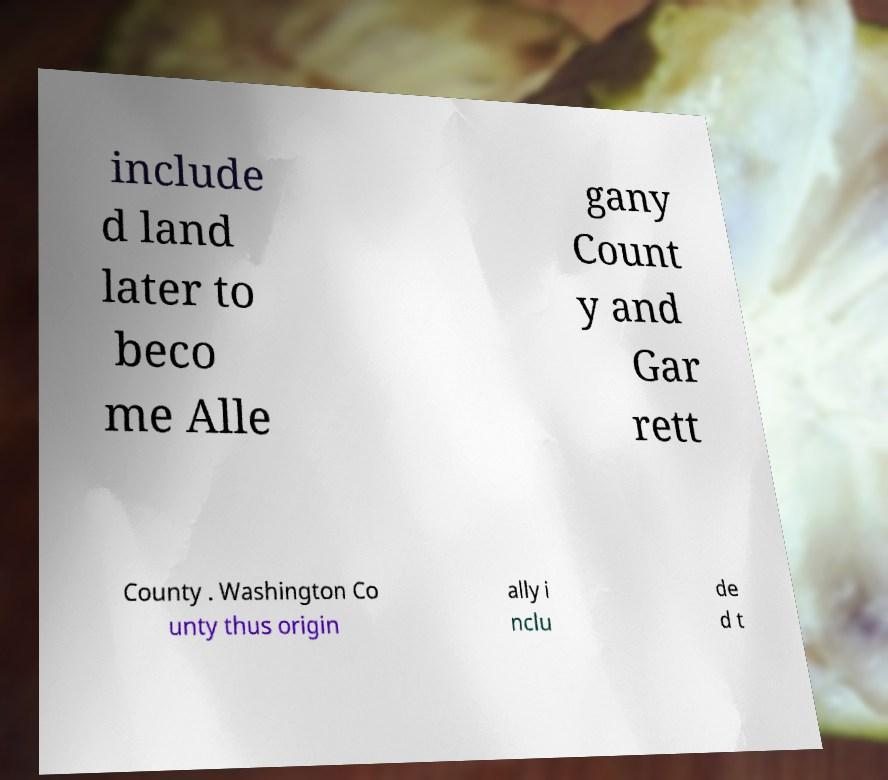Can you read and provide the text displayed in the image?This photo seems to have some interesting text. Can you extract and type it out for me? include d land later to beco me Alle gany Count y and Gar rett County . Washington Co unty thus origin ally i nclu de d t 